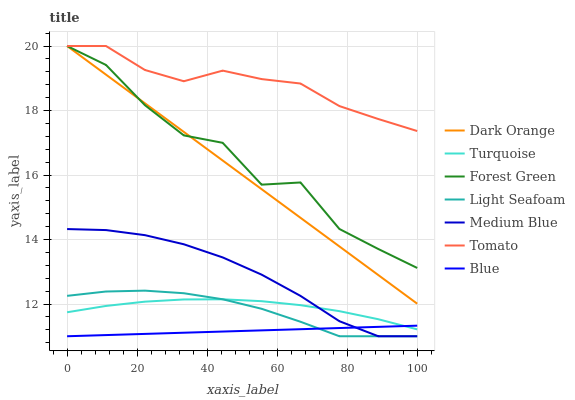Does Dark Orange have the minimum area under the curve?
Answer yes or no. No. Does Dark Orange have the maximum area under the curve?
Answer yes or no. No. Is Dark Orange the smoothest?
Answer yes or no. No. Is Dark Orange the roughest?
Answer yes or no. No. Does Dark Orange have the lowest value?
Answer yes or no. No. Does Turquoise have the highest value?
Answer yes or no. No. Is Light Seafoam less than Tomato?
Answer yes or no. Yes. Is Forest Green greater than Medium Blue?
Answer yes or no. Yes. Does Light Seafoam intersect Tomato?
Answer yes or no. No. 